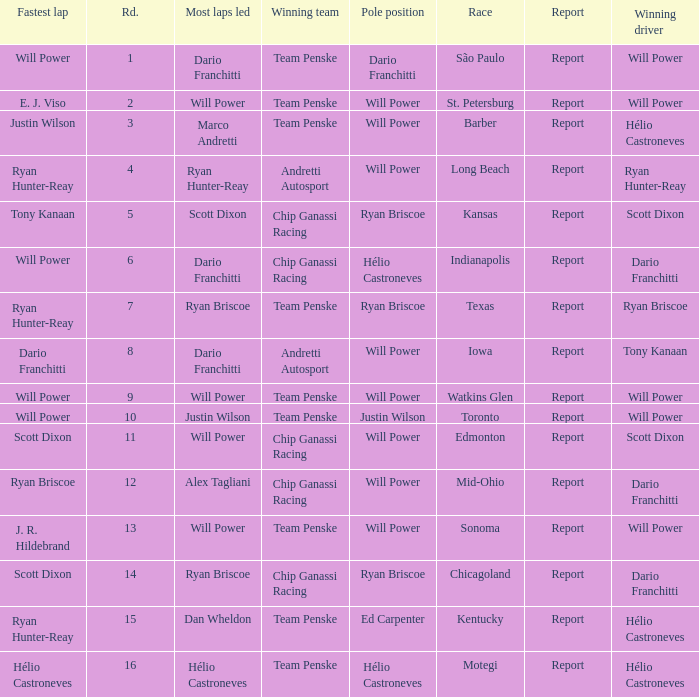What is the report for races where Will Power had both pole position and fastest lap? Report. 